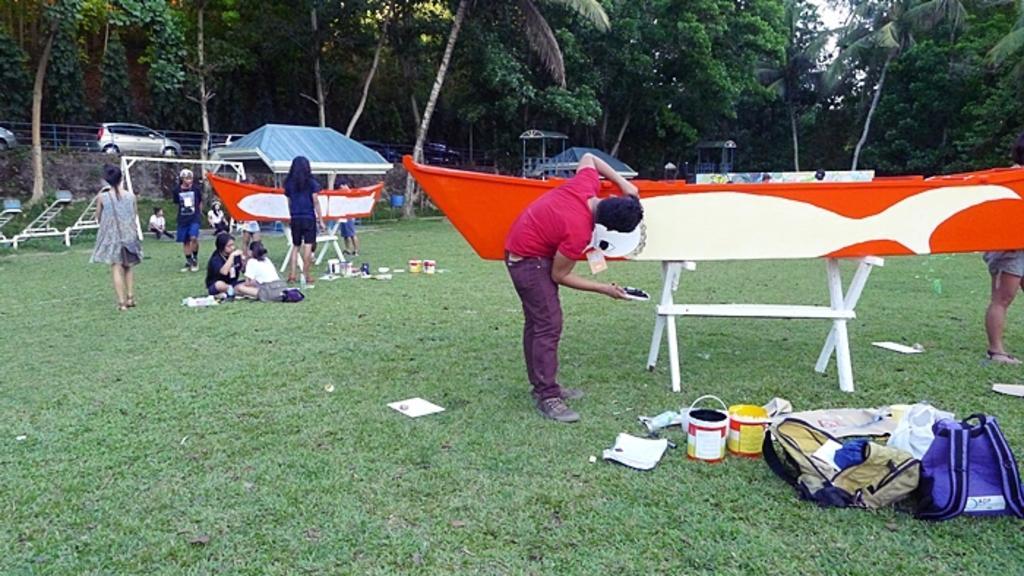Describe this image in one or two sentences. In this image, we can see trees, vehicles on the road and there is a fence and some tents and there are boards with stands and we can see people, some are wearing id cards and one of them is wearing a bag and there is a person holding an object. At the bottom, there are paint buckets, bags, papers and some other objects on the ground and we can see some people sitting. 